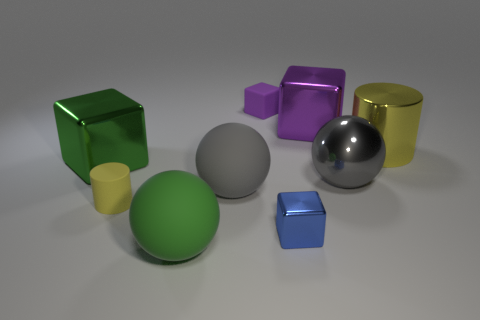How many purple cubes must be subtracted to get 1 purple cubes? 1 Subtract 1 cubes. How many cubes are left? 3 Add 1 yellow metallic cylinders. How many objects exist? 10 Subtract all cylinders. How many objects are left? 7 Add 2 matte cylinders. How many matte cylinders exist? 3 Subtract 0 purple cylinders. How many objects are left? 9 Subtract all spheres. Subtract all tiny cylinders. How many objects are left? 5 Add 5 green matte spheres. How many green matte spheres are left? 6 